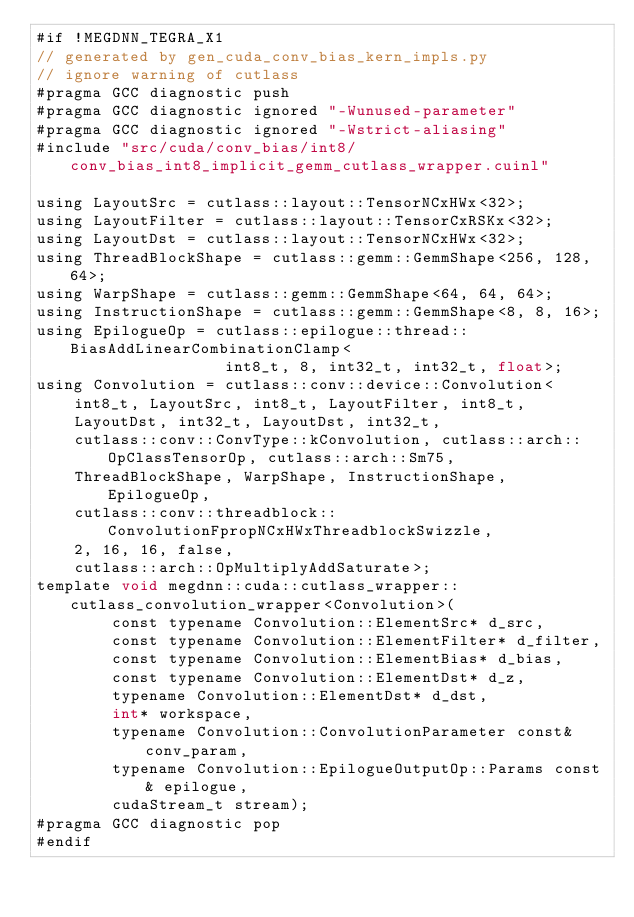<code> <loc_0><loc_0><loc_500><loc_500><_Cuda_>#if !MEGDNN_TEGRA_X1
// generated by gen_cuda_conv_bias_kern_impls.py
// ignore warning of cutlass
#pragma GCC diagnostic push
#pragma GCC diagnostic ignored "-Wunused-parameter"
#pragma GCC diagnostic ignored "-Wstrict-aliasing"
#include "src/cuda/conv_bias/int8/conv_bias_int8_implicit_gemm_cutlass_wrapper.cuinl"

using LayoutSrc = cutlass::layout::TensorNCxHWx<32>;
using LayoutFilter = cutlass::layout::TensorCxRSKx<32>;
using LayoutDst = cutlass::layout::TensorNCxHWx<32>;
using ThreadBlockShape = cutlass::gemm::GemmShape<256, 128, 64>;
using WarpShape = cutlass::gemm::GemmShape<64, 64, 64>;
using InstructionShape = cutlass::gemm::GemmShape<8, 8, 16>;
using EpilogueOp = cutlass::epilogue::thread::BiasAddLinearCombinationClamp<
                    int8_t, 8, int32_t, int32_t, float>;
using Convolution = cutlass::conv::device::Convolution<
    int8_t, LayoutSrc, int8_t, LayoutFilter, int8_t, 
    LayoutDst, int32_t, LayoutDst, int32_t, 
    cutlass::conv::ConvType::kConvolution, cutlass::arch::OpClassTensorOp, cutlass::arch::Sm75, 
    ThreadBlockShape, WarpShape, InstructionShape, EpilogueOp, 
    cutlass::conv::threadblock::ConvolutionFpropNCxHWxThreadblockSwizzle, 
    2, 16, 16, false, 
    cutlass::arch::OpMultiplyAddSaturate>;
template void megdnn::cuda::cutlass_wrapper::cutlass_convolution_wrapper<Convolution>(
        const typename Convolution::ElementSrc* d_src, 
        const typename Convolution::ElementFilter* d_filter, 
        const typename Convolution::ElementBias* d_bias, 
        const typename Convolution::ElementDst* d_z, 
        typename Convolution::ElementDst* d_dst, 
        int* workspace, 
        typename Convolution::ConvolutionParameter const& conv_param, 
        typename Convolution::EpilogueOutputOp::Params const& epilogue, 
        cudaStream_t stream);
#pragma GCC diagnostic pop
#endif
</code> 